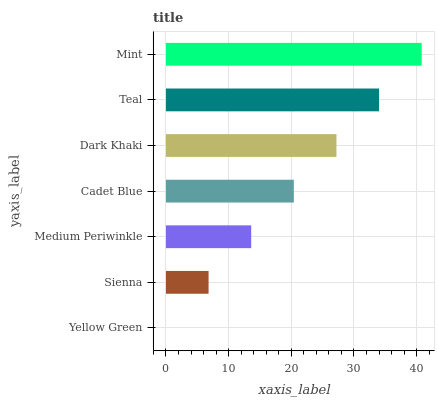Is Yellow Green the minimum?
Answer yes or no. Yes. Is Mint the maximum?
Answer yes or no. Yes. Is Sienna the minimum?
Answer yes or no. No. Is Sienna the maximum?
Answer yes or no. No. Is Sienna greater than Yellow Green?
Answer yes or no. Yes. Is Yellow Green less than Sienna?
Answer yes or no. Yes. Is Yellow Green greater than Sienna?
Answer yes or no. No. Is Sienna less than Yellow Green?
Answer yes or no. No. Is Cadet Blue the high median?
Answer yes or no. Yes. Is Cadet Blue the low median?
Answer yes or no. Yes. Is Teal the high median?
Answer yes or no. No. Is Sienna the low median?
Answer yes or no. No. 